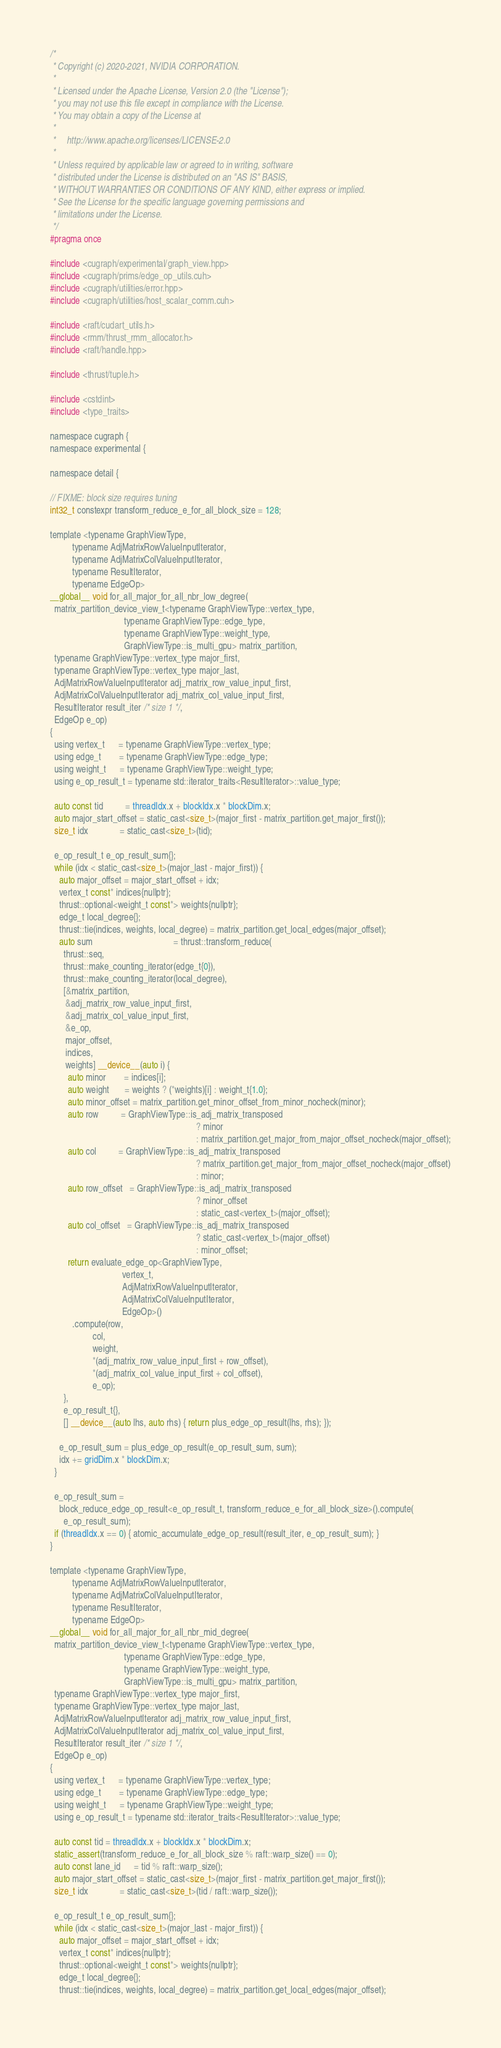Convert code to text. <code><loc_0><loc_0><loc_500><loc_500><_Cuda_>/*
 * Copyright (c) 2020-2021, NVIDIA CORPORATION.
 *
 * Licensed under the Apache License, Version 2.0 (the "License");
 * you may not use this file except in compliance with the License.
 * You may obtain a copy of the License at
 *
 *     http://www.apache.org/licenses/LICENSE-2.0
 *
 * Unless required by applicable law or agreed to in writing, software
 * distributed under the License is distributed on an "AS IS" BASIS,
 * WITHOUT WARRANTIES OR CONDITIONS OF ANY KIND, either express or implied.
 * See the License for the specific language governing permissions and
 * limitations under the License.
 */
#pragma once

#include <cugraph/experimental/graph_view.hpp>
#include <cugraph/prims/edge_op_utils.cuh>
#include <cugraph/utilities/error.hpp>
#include <cugraph/utilities/host_scalar_comm.cuh>

#include <raft/cudart_utils.h>
#include <rmm/thrust_rmm_allocator.h>
#include <raft/handle.hpp>

#include <thrust/tuple.h>

#include <cstdint>
#include <type_traits>

namespace cugraph {
namespace experimental {

namespace detail {

// FIXME: block size requires tuning
int32_t constexpr transform_reduce_e_for_all_block_size = 128;

template <typename GraphViewType,
          typename AdjMatrixRowValueInputIterator,
          typename AdjMatrixColValueInputIterator,
          typename ResultIterator,
          typename EdgeOp>
__global__ void for_all_major_for_all_nbr_low_degree(
  matrix_partition_device_view_t<typename GraphViewType::vertex_type,
                                 typename GraphViewType::edge_type,
                                 typename GraphViewType::weight_type,
                                 GraphViewType::is_multi_gpu> matrix_partition,
  typename GraphViewType::vertex_type major_first,
  typename GraphViewType::vertex_type major_last,
  AdjMatrixRowValueInputIterator adj_matrix_row_value_input_first,
  AdjMatrixColValueInputIterator adj_matrix_col_value_input_first,
  ResultIterator result_iter /* size 1 */,
  EdgeOp e_op)
{
  using vertex_t      = typename GraphViewType::vertex_type;
  using edge_t        = typename GraphViewType::edge_type;
  using weight_t      = typename GraphViewType::weight_type;
  using e_op_result_t = typename std::iterator_traits<ResultIterator>::value_type;

  auto const tid          = threadIdx.x + blockIdx.x * blockDim.x;
  auto major_start_offset = static_cast<size_t>(major_first - matrix_partition.get_major_first());
  size_t idx              = static_cast<size_t>(tid);

  e_op_result_t e_op_result_sum{};
  while (idx < static_cast<size_t>(major_last - major_first)) {
    auto major_offset = major_start_offset + idx;
    vertex_t const* indices{nullptr};
    thrust::optional<weight_t const*> weights{nullptr};
    edge_t local_degree{};
    thrust::tie(indices, weights, local_degree) = matrix_partition.get_local_edges(major_offset);
    auto sum                                    = thrust::transform_reduce(
      thrust::seq,
      thrust::make_counting_iterator(edge_t{0}),
      thrust::make_counting_iterator(local_degree),
      [&matrix_partition,
       &adj_matrix_row_value_input_first,
       &adj_matrix_col_value_input_first,
       &e_op,
       major_offset,
       indices,
       weights] __device__(auto i) {
        auto minor        = indices[i];
        auto weight       = weights ? (*weights)[i] : weight_t{1.0};
        auto minor_offset = matrix_partition.get_minor_offset_from_minor_nocheck(minor);
        auto row          = GraphViewType::is_adj_matrix_transposed
                                                                 ? minor
                                                                 : matrix_partition.get_major_from_major_offset_nocheck(major_offset);
        auto col          = GraphViewType::is_adj_matrix_transposed
                                                                 ? matrix_partition.get_major_from_major_offset_nocheck(major_offset)
                                                                 : minor;
        auto row_offset   = GraphViewType::is_adj_matrix_transposed
                                                                 ? minor_offset
                                                                 : static_cast<vertex_t>(major_offset);
        auto col_offset   = GraphViewType::is_adj_matrix_transposed
                                                                 ? static_cast<vertex_t>(major_offset)
                                                                 : minor_offset;
        return evaluate_edge_op<GraphViewType,
                                vertex_t,
                                AdjMatrixRowValueInputIterator,
                                AdjMatrixColValueInputIterator,
                                EdgeOp>()
          .compute(row,
                   col,
                   weight,
                   *(adj_matrix_row_value_input_first + row_offset),
                   *(adj_matrix_col_value_input_first + col_offset),
                   e_op);
      },
      e_op_result_t{},
      [] __device__(auto lhs, auto rhs) { return plus_edge_op_result(lhs, rhs); });

    e_op_result_sum = plus_edge_op_result(e_op_result_sum, sum);
    idx += gridDim.x * blockDim.x;
  }

  e_op_result_sum =
    block_reduce_edge_op_result<e_op_result_t, transform_reduce_e_for_all_block_size>().compute(
      e_op_result_sum);
  if (threadIdx.x == 0) { atomic_accumulate_edge_op_result(result_iter, e_op_result_sum); }
}

template <typename GraphViewType,
          typename AdjMatrixRowValueInputIterator,
          typename AdjMatrixColValueInputIterator,
          typename ResultIterator,
          typename EdgeOp>
__global__ void for_all_major_for_all_nbr_mid_degree(
  matrix_partition_device_view_t<typename GraphViewType::vertex_type,
                                 typename GraphViewType::edge_type,
                                 typename GraphViewType::weight_type,
                                 GraphViewType::is_multi_gpu> matrix_partition,
  typename GraphViewType::vertex_type major_first,
  typename GraphViewType::vertex_type major_last,
  AdjMatrixRowValueInputIterator adj_matrix_row_value_input_first,
  AdjMatrixColValueInputIterator adj_matrix_col_value_input_first,
  ResultIterator result_iter /* size 1 */,
  EdgeOp e_op)
{
  using vertex_t      = typename GraphViewType::vertex_type;
  using edge_t        = typename GraphViewType::edge_type;
  using weight_t      = typename GraphViewType::weight_type;
  using e_op_result_t = typename std::iterator_traits<ResultIterator>::value_type;

  auto const tid = threadIdx.x + blockIdx.x * blockDim.x;
  static_assert(transform_reduce_e_for_all_block_size % raft::warp_size() == 0);
  auto const lane_id      = tid % raft::warp_size();
  auto major_start_offset = static_cast<size_t>(major_first - matrix_partition.get_major_first());
  size_t idx              = static_cast<size_t>(tid / raft::warp_size());

  e_op_result_t e_op_result_sum{};
  while (idx < static_cast<size_t>(major_last - major_first)) {
    auto major_offset = major_start_offset + idx;
    vertex_t const* indices{nullptr};
    thrust::optional<weight_t const*> weights{nullptr};
    edge_t local_degree{};
    thrust::tie(indices, weights, local_degree) = matrix_partition.get_local_edges(major_offset);</code> 